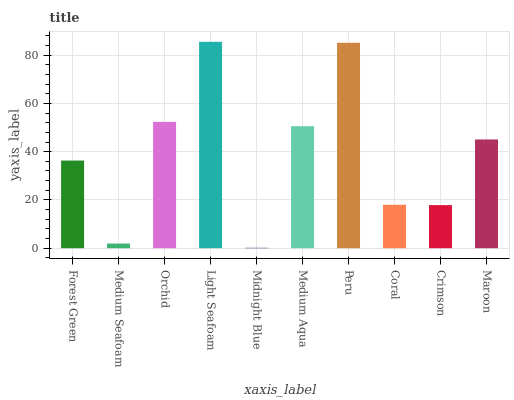Is Midnight Blue the minimum?
Answer yes or no. Yes. Is Light Seafoam the maximum?
Answer yes or no. Yes. Is Medium Seafoam the minimum?
Answer yes or no. No. Is Medium Seafoam the maximum?
Answer yes or no. No. Is Forest Green greater than Medium Seafoam?
Answer yes or no. Yes. Is Medium Seafoam less than Forest Green?
Answer yes or no. Yes. Is Medium Seafoam greater than Forest Green?
Answer yes or no. No. Is Forest Green less than Medium Seafoam?
Answer yes or no. No. Is Maroon the high median?
Answer yes or no. Yes. Is Forest Green the low median?
Answer yes or no. Yes. Is Orchid the high median?
Answer yes or no. No. Is Orchid the low median?
Answer yes or no. No. 